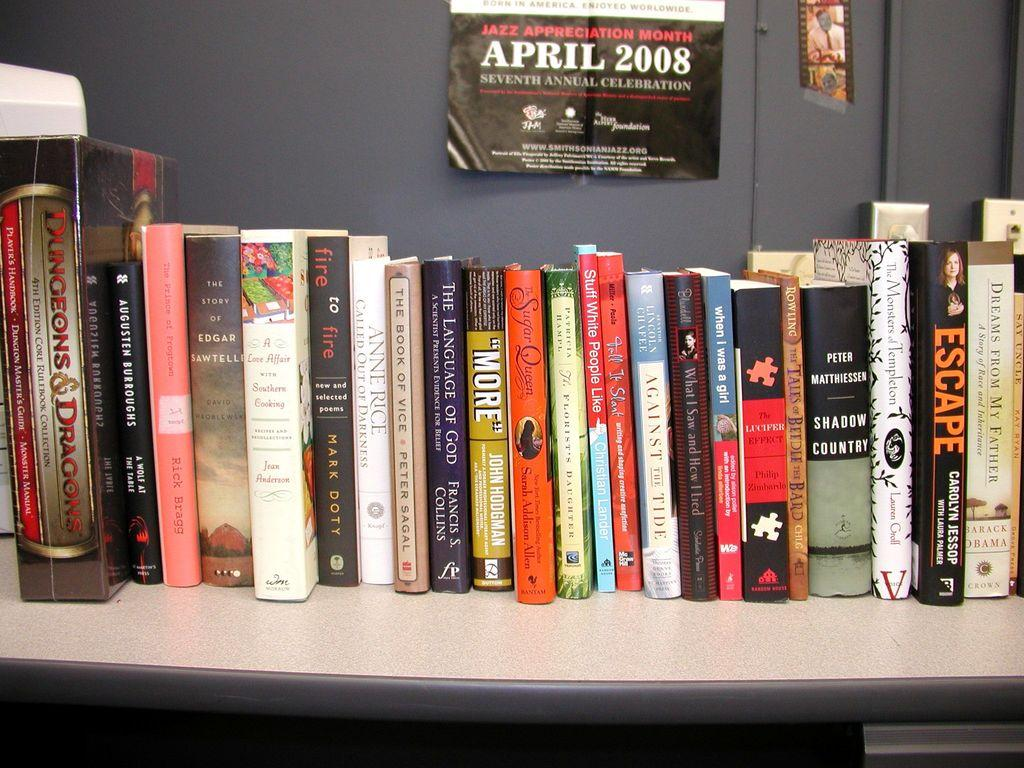<image>
Offer a succinct explanation of the picture presented. A poster promoting 2008's jazz appreciation month is posted above a row of books from varied genres. 